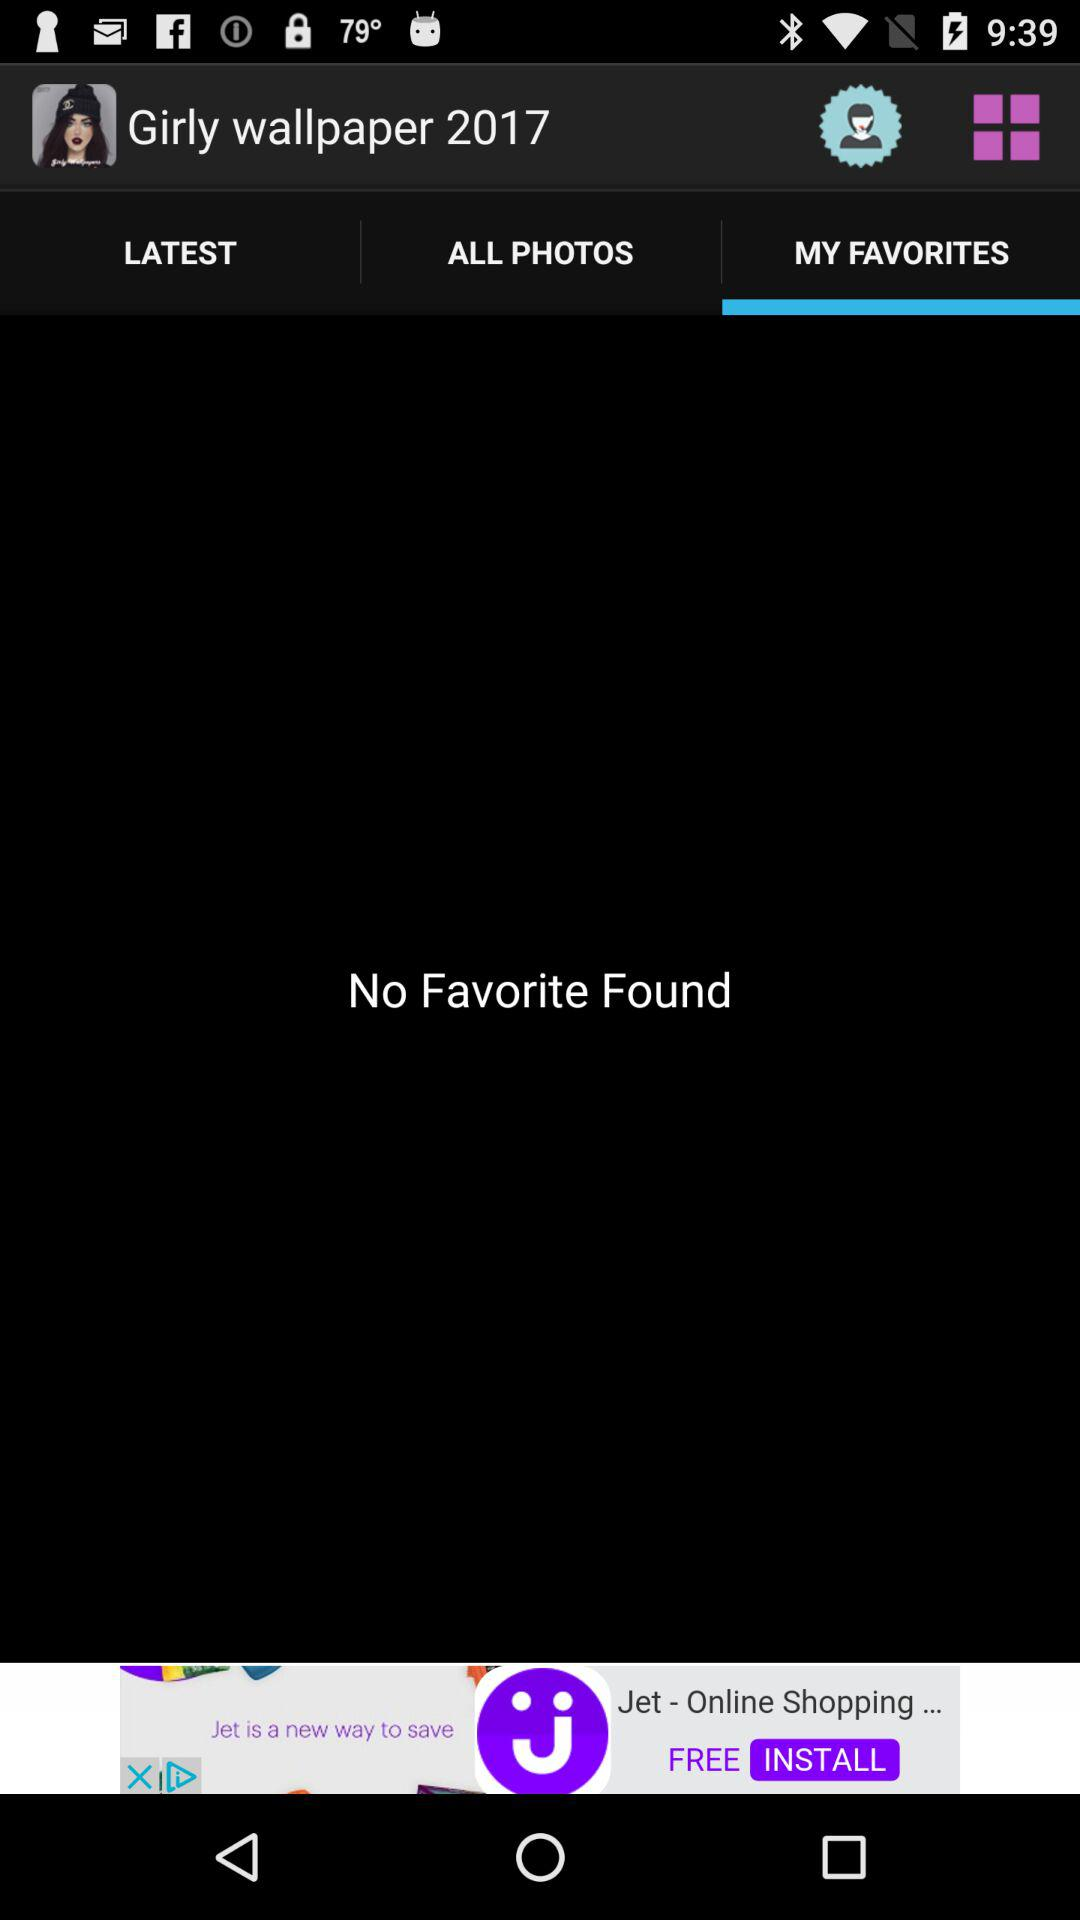What is the year of "Girly wallpaper"? The year is 2017. 